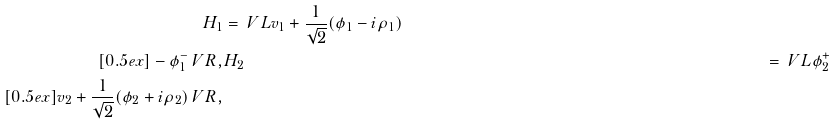Convert formula to latex. <formula><loc_0><loc_0><loc_500><loc_500>H _ { 1 } & = \ V L v _ { 1 } + \frac { 1 } { \sqrt { 2 } } ( \phi _ { 1 } - i \rho _ { 1 } ) \\ [ 0 . 5 e x ] - \phi _ { 1 } ^ { - } \ V R , & H _ { 2 } & = \ V L \phi _ { 2 } ^ { + } \\ [ 0 . 5 e x ] v _ { 2 } + \frac { 1 } { \sqrt { 2 } } ( \phi _ { 2 } + i \rho _ { 2 } ) \ V R ,</formula> 